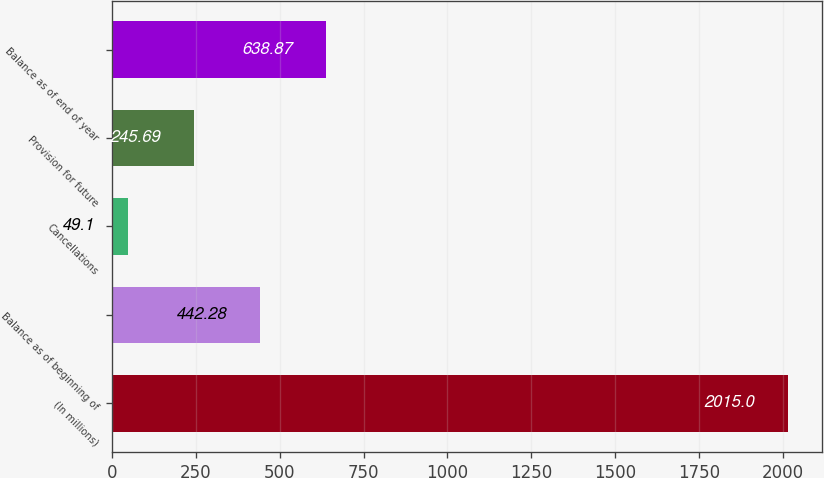Convert chart to OTSL. <chart><loc_0><loc_0><loc_500><loc_500><bar_chart><fcel>(In millions)<fcel>Balance as of beginning of<fcel>Cancellations<fcel>Provision for future<fcel>Balance as of end of year<nl><fcel>2015<fcel>442.28<fcel>49.1<fcel>245.69<fcel>638.87<nl></chart> 